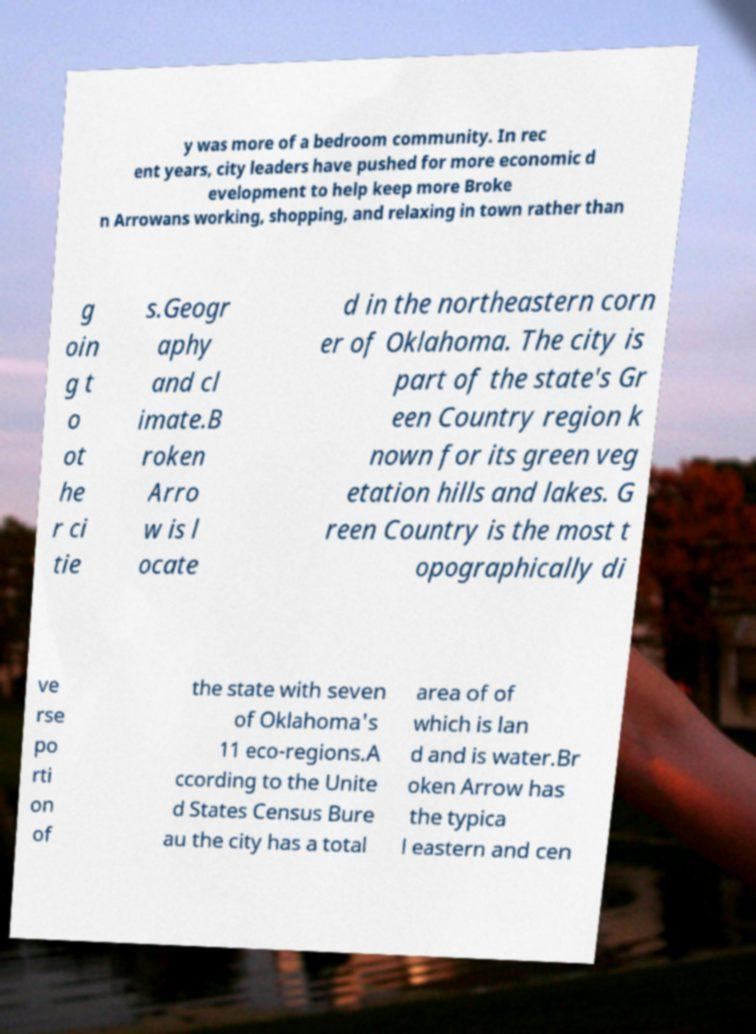Can you read and provide the text displayed in the image?This photo seems to have some interesting text. Can you extract and type it out for me? y was more of a bedroom community. In rec ent years, city leaders have pushed for more economic d evelopment to help keep more Broke n Arrowans working, shopping, and relaxing in town rather than g oin g t o ot he r ci tie s.Geogr aphy and cl imate.B roken Arro w is l ocate d in the northeastern corn er of Oklahoma. The city is part of the state's Gr een Country region k nown for its green veg etation hills and lakes. G reen Country is the most t opographically di ve rse po rti on of the state with seven of Oklahoma's 11 eco-regions.A ccording to the Unite d States Census Bure au the city has a total area of of which is lan d and is water.Br oken Arrow has the typica l eastern and cen 